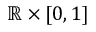Convert formula to latex. <formula><loc_0><loc_0><loc_500><loc_500>\mathbb { R } \times [ 0 , 1 ]</formula> 